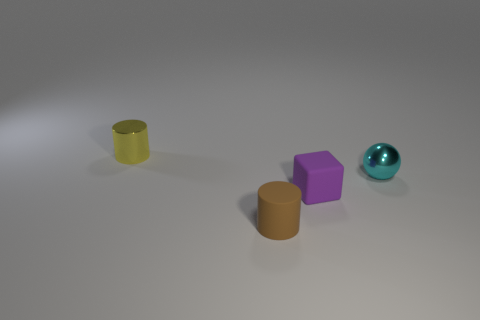What size is the rubber block?
Ensure brevity in your answer.  Small. The tiny yellow object that is made of the same material as the ball is what shape?
Your answer should be very brief. Cylinder. Does the shiny thing left of the small brown matte object have the same shape as the cyan metal object?
Provide a short and direct response. No. What number of things are either tiny yellow things or small blocks?
Your response must be concise. 2. What is the object that is both behind the small matte cylinder and in front of the small sphere made of?
Keep it short and to the point. Rubber. Do the brown matte object and the yellow metallic cylinder have the same size?
Provide a short and direct response. Yes. There is a metallic object that is right of the cylinder that is to the left of the tiny matte cylinder; how big is it?
Give a very brief answer. Small. How many tiny objects are behind the purple thing and to the right of the brown rubber thing?
Give a very brief answer. 1. Is there a tiny cyan sphere behind the tiny metallic thing that is on the right side of the shiny thing left of the tiny ball?
Your answer should be compact. No. What is the shape of the yellow object that is the same size as the brown rubber cylinder?
Your answer should be compact. Cylinder. 